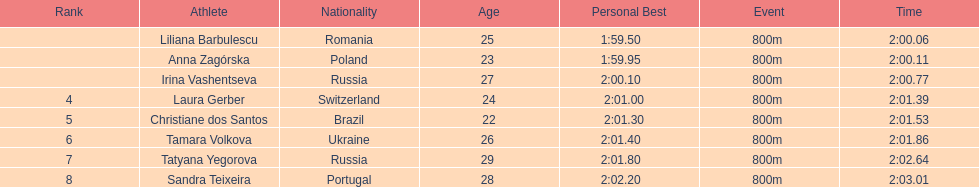What is the name of the top finalist of this semifinals heat? Liliana Barbulescu. 